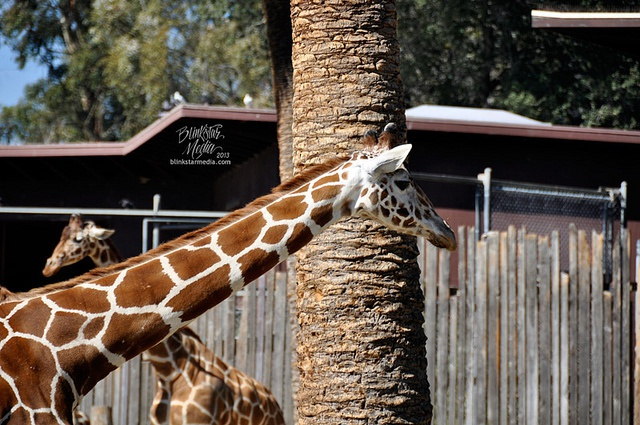Describe the objects in this image and their specific colors. I can see giraffe in gray, brown, black, maroon, and white tones and giraffe in gray, black, maroon, and tan tones in this image. 